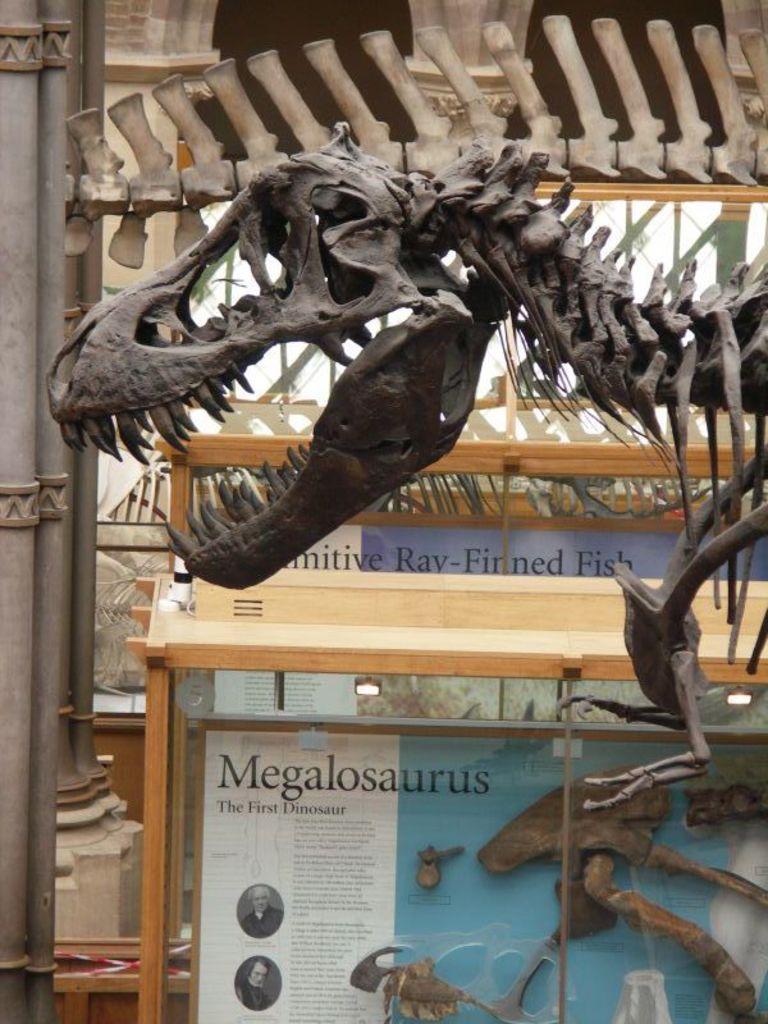Please provide a concise description of this image. In this image I can see the skeleton of an animal. I can see few poles and few boards in which I can see few posters to it. 